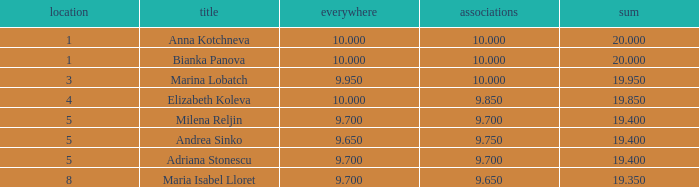What are the lowest clubs that have a place greater than 5, with an all around greater than 9.7? None. 